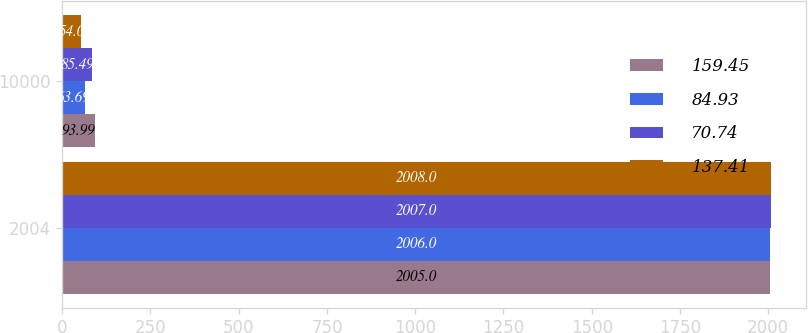<chart> <loc_0><loc_0><loc_500><loc_500><stacked_bar_chart><ecel><fcel>2004<fcel>10000<nl><fcel>159.45<fcel>2005<fcel>93.99<nl><fcel>84.93<fcel>2006<fcel>63.69<nl><fcel>70.74<fcel>2007<fcel>85.49<nl><fcel>137.41<fcel>2008<fcel>54<nl></chart> 